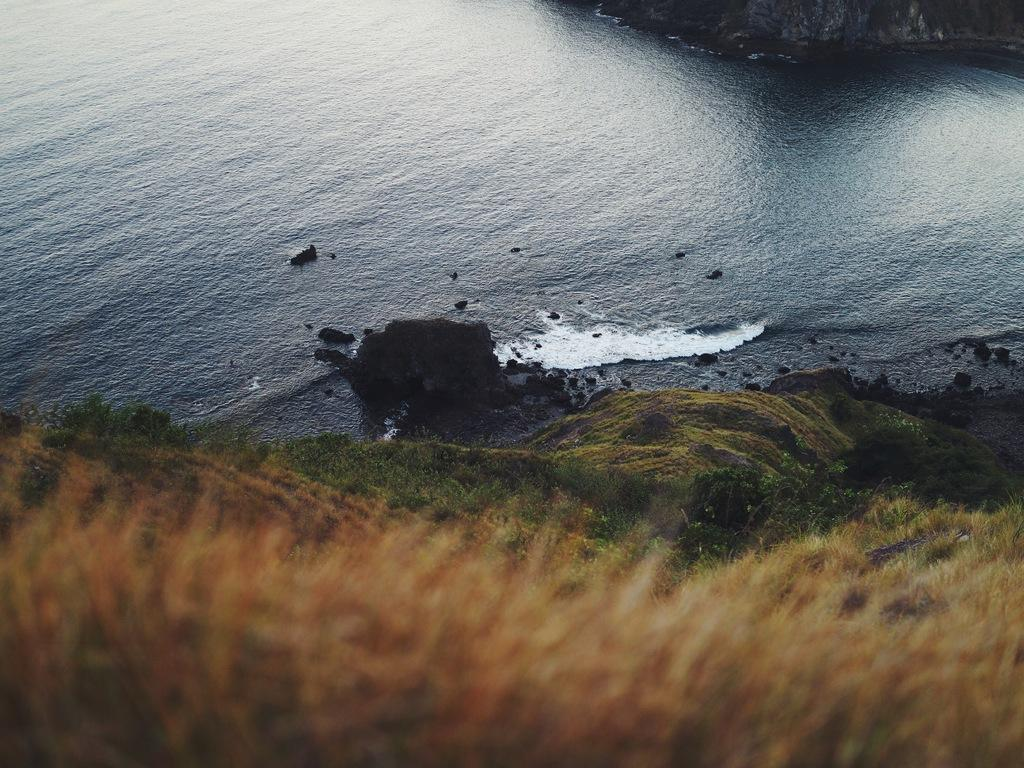What type of vegetation is visible at the bottom of the image? There is grass on the bottom side of the image. What natural element is present in the middle of the image? There is water in the middle of the image. What type of bun is used to create the design in the image? There is no bun or design present in the image; it features grass and water. How does the toothbrush contribute to the image's composition? There is no toothbrush present in the image. 